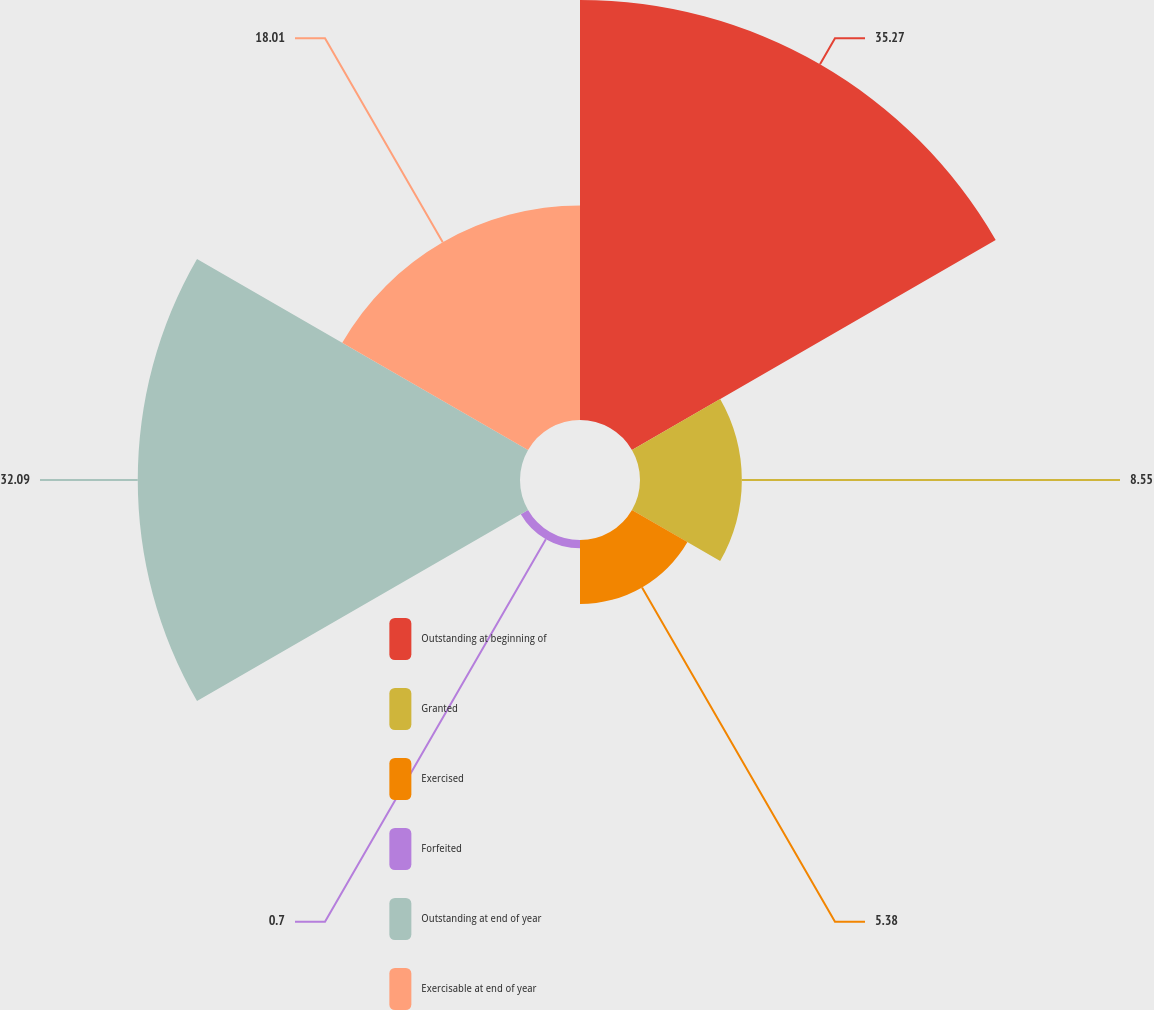<chart> <loc_0><loc_0><loc_500><loc_500><pie_chart><fcel>Outstanding at beginning of<fcel>Granted<fcel>Exercised<fcel>Forfeited<fcel>Outstanding at end of year<fcel>Exercisable at end of year<nl><fcel>35.26%<fcel>8.55%<fcel>5.38%<fcel>0.7%<fcel>32.09%<fcel>18.01%<nl></chart> 